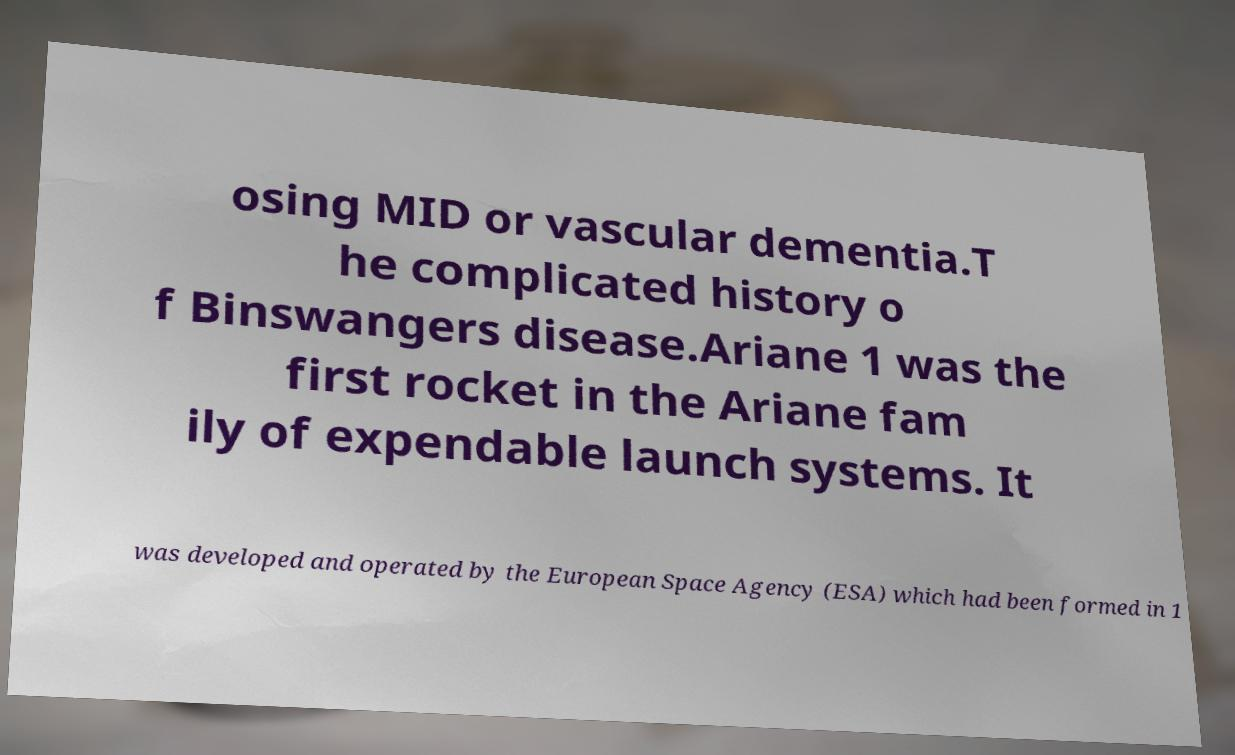Could you assist in decoding the text presented in this image and type it out clearly? osing MID or vascular dementia.T he complicated history o f Binswangers disease.Ariane 1 was the first rocket in the Ariane fam ily of expendable launch systems. It was developed and operated by the European Space Agency (ESA) which had been formed in 1 